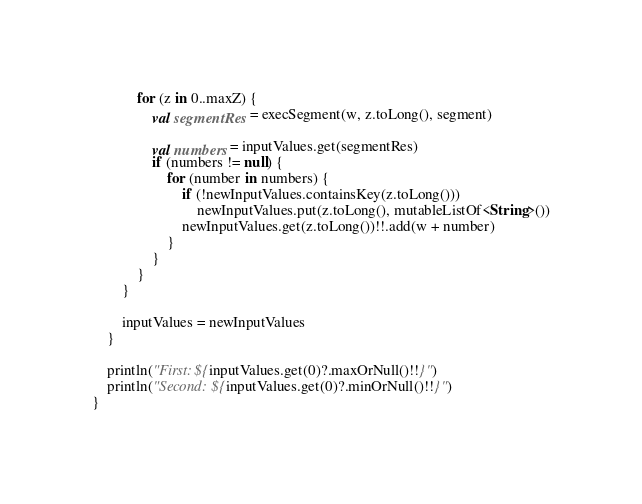Convert code to text. <code><loc_0><loc_0><loc_500><loc_500><_Kotlin_>            for (z in 0..maxZ) {
                val segmentRes = execSegment(w, z.toLong(), segment)

                val numbers = inputValues.get(segmentRes)
                if (numbers != null) {
                    for (number in numbers) {
                        if (!newInputValues.containsKey(z.toLong()))
                            newInputValues.put(z.toLong(), mutableListOf<String>())
                        newInputValues.get(z.toLong())!!.add(w + number)
                    }
                }
            }
        }

        inputValues = newInputValues
    }

    println("First: ${inputValues.get(0)?.maxOrNull()!!}")
    println("Second: ${inputValues.get(0)?.minOrNull()!!}")
}
</code> 